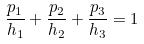Convert formula to latex. <formula><loc_0><loc_0><loc_500><loc_500>\frac { p _ { 1 } } { h _ { 1 } } + \frac { p _ { 2 } } { h _ { 2 } } + \frac { p _ { 3 } } { h _ { 3 } } = 1</formula> 